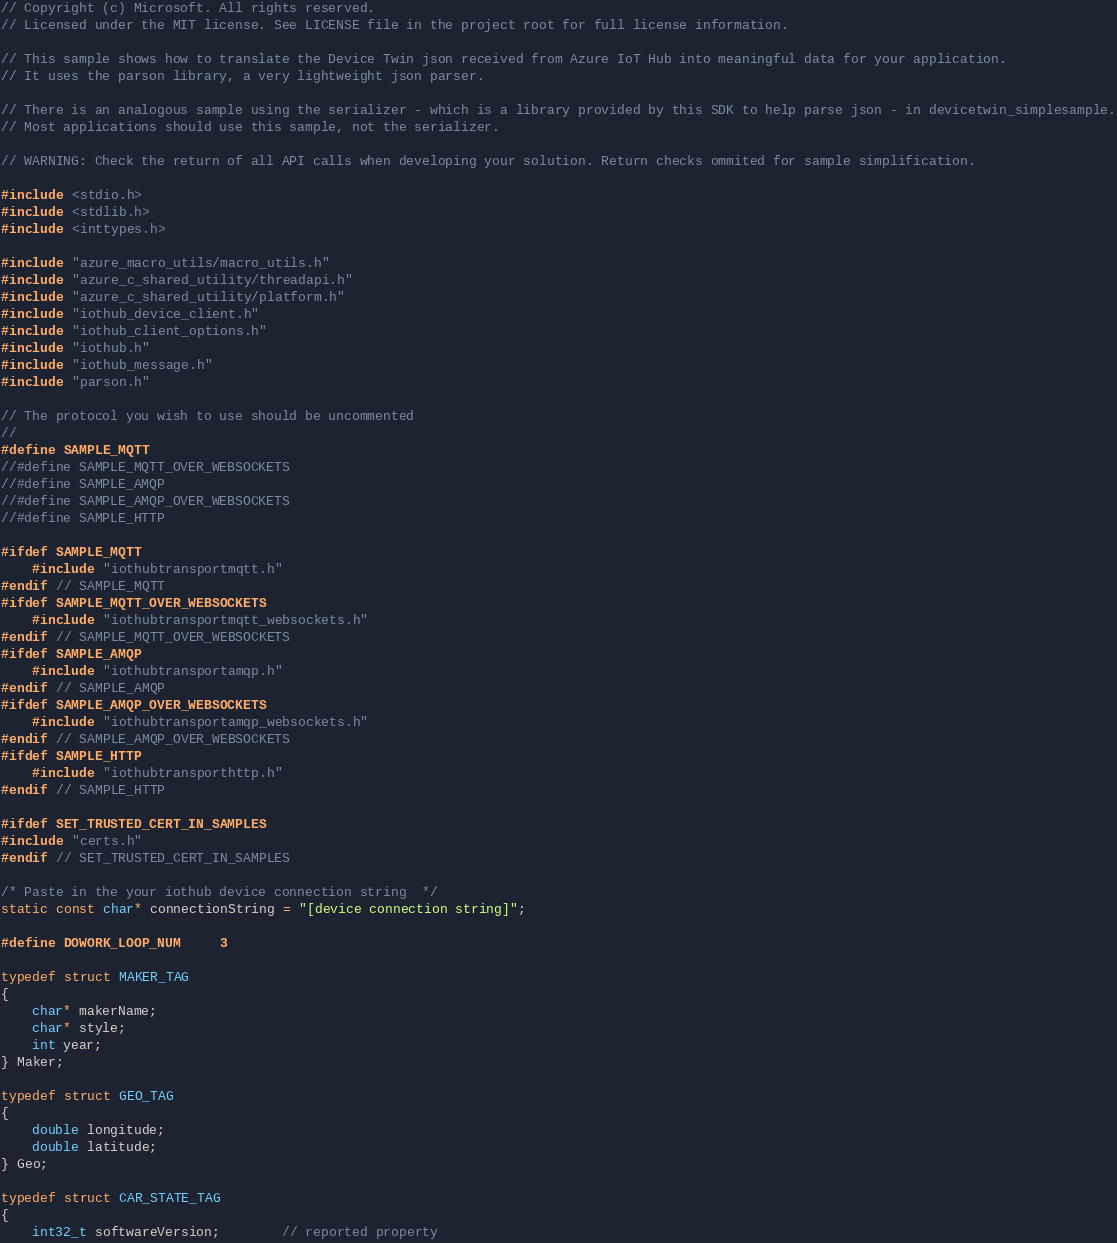Convert code to text. <code><loc_0><loc_0><loc_500><loc_500><_C_>// Copyright (c) Microsoft. All rights reserved.
// Licensed under the MIT license. See LICENSE file in the project root for full license information.

// This sample shows how to translate the Device Twin json received from Azure IoT Hub into meaningful data for your application.
// It uses the parson library, a very lightweight json parser.

// There is an analogous sample using the serializer - which is a library provided by this SDK to help parse json - in devicetwin_simplesample.
// Most applications should use this sample, not the serializer.

// WARNING: Check the return of all API calls when developing your solution. Return checks ommited for sample simplification.

#include <stdio.h>
#include <stdlib.h>
#include <inttypes.h>

#include "azure_macro_utils/macro_utils.h"
#include "azure_c_shared_utility/threadapi.h"
#include "azure_c_shared_utility/platform.h"
#include "iothub_device_client.h"
#include "iothub_client_options.h"
#include "iothub.h"
#include "iothub_message.h"
#include "parson.h"

// The protocol you wish to use should be uncommented
//
#define SAMPLE_MQTT
//#define SAMPLE_MQTT_OVER_WEBSOCKETS
//#define SAMPLE_AMQP
//#define SAMPLE_AMQP_OVER_WEBSOCKETS
//#define SAMPLE_HTTP

#ifdef SAMPLE_MQTT
    #include "iothubtransportmqtt.h"
#endif // SAMPLE_MQTT
#ifdef SAMPLE_MQTT_OVER_WEBSOCKETS
    #include "iothubtransportmqtt_websockets.h"
#endif // SAMPLE_MQTT_OVER_WEBSOCKETS
#ifdef SAMPLE_AMQP
    #include "iothubtransportamqp.h"
#endif // SAMPLE_AMQP
#ifdef SAMPLE_AMQP_OVER_WEBSOCKETS
    #include "iothubtransportamqp_websockets.h"
#endif // SAMPLE_AMQP_OVER_WEBSOCKETS
#ifdef SAMPLE_HTTP
    #include "iothubtransporthttp.h"
#endif // SAMPLE_HTTP

#ifdef SET_TRUSTED_CERT_IN_SAMPLES
#include "certs.h"
#endif // SET_TRUSTED_CERT_IN_SAMPLES

/* Paste in the your iothub device connection string  */
static const char* connectionString = "[device connection string]";

#define DOWORK_LOOP_NUM     3

typedef struct MAKER_TAG
{
    char* makerName;
    char* style;
    int year;
} Maker;

typedef struct GEO_TAG
{
    double longitude;
    double latitude;
} Geo;

typedef struct CAR_STATE_TAG
{
    int32_t softwareVersion;        // reported property</code> 